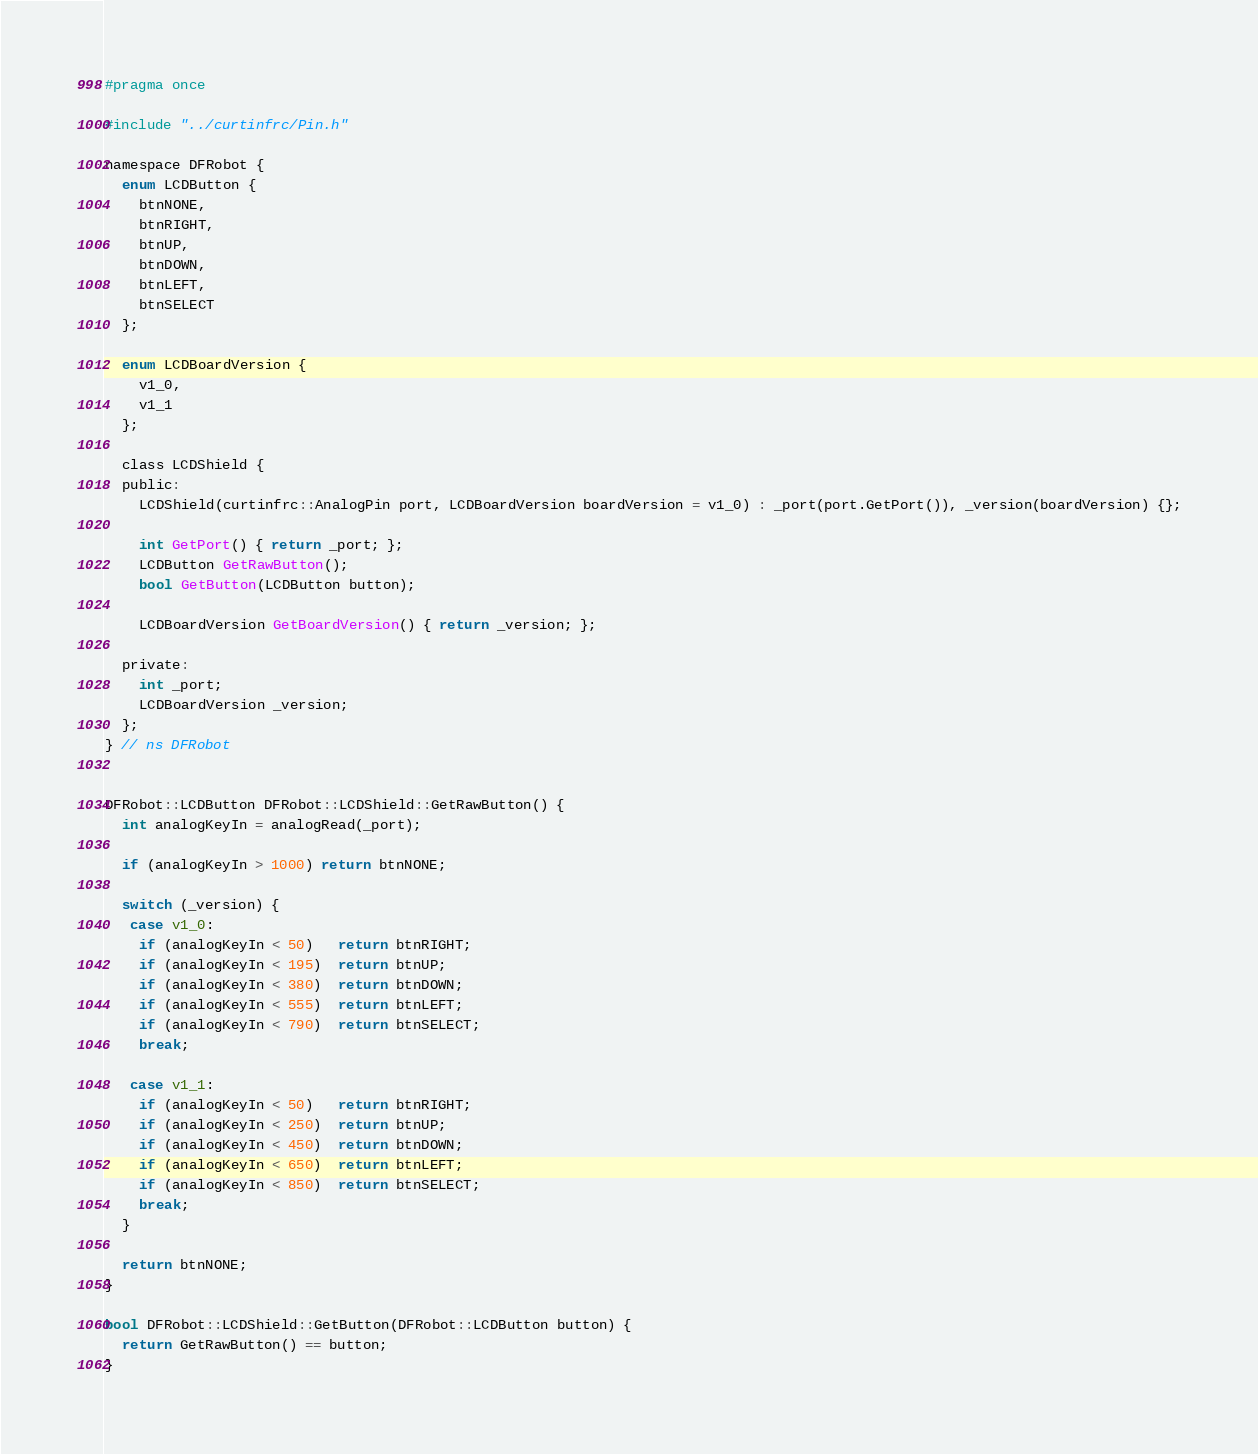<code> <loc_0><loc_0><loc_500><loc_500><_C_>#pragma once

#include "../curtinfrc/Pin.h"

namespace DFRobot {
  enum LCDButton {
    btnNONE,
    btnRIGHT,
    btnUP,
    btnDOWN,
    btnLEFT,
    btnSELECT
  };

  enum LCDBoardVersion {
    v1_0,
    v1_1
  };

  class LCDShield {
  public:
    LCDShield(curtinfrc::AnalogPin port, LCDBoardVersion boardVersion = v1_0) : _port(port.GetPort()), _version(boardVersion) {};

    int GetPort() { return _port; };
    LCDButton GetRawButton();
    bool GetButton(LCDButton button);

    LCDBoardVersion GetBoardVersion() { return _version; };

  private:
    int _port;
    LCDBoardVersion _version;
  };
} // ns DFRobot


DFRobot::LCDButton DFRobot::LCDShield::GetRawButton() {
  int analogKeyIn = analogRead(_port);

  if (analogKeyIn > 1000) return btnNONE;

  switch (_version) {
   case v1_0:
    if (analogKeyIn < 50)   return btnRIGHT;
    if (analogKeyIn < 195)  return btnUP;
    if (analogKeyIn < 380)  return btnDOWN;
    if (analogKeyIn < 555)  return btnLEFT;
    if (analogKeyIn < 790)  return btnSELECT;
    break;

   case v1_1:
    if (analogKeyIn < 50)   return btnRIGHT;
    if (analogKeyIn < 250)  return btnUP;
    if (analogKeyIn < 450)  return btnDOWN;
    if (analogKeyIn < 650)  return btnLEFT;
    if (analogKeyIn < 850)  return btnSELECT;
    break;
  }

  return btnNONE;
}

bool DFRobot::LCDShield::GetButton(DFRobot::LCDButton button) {
  return GetRawButton() == button;
}
</code> 